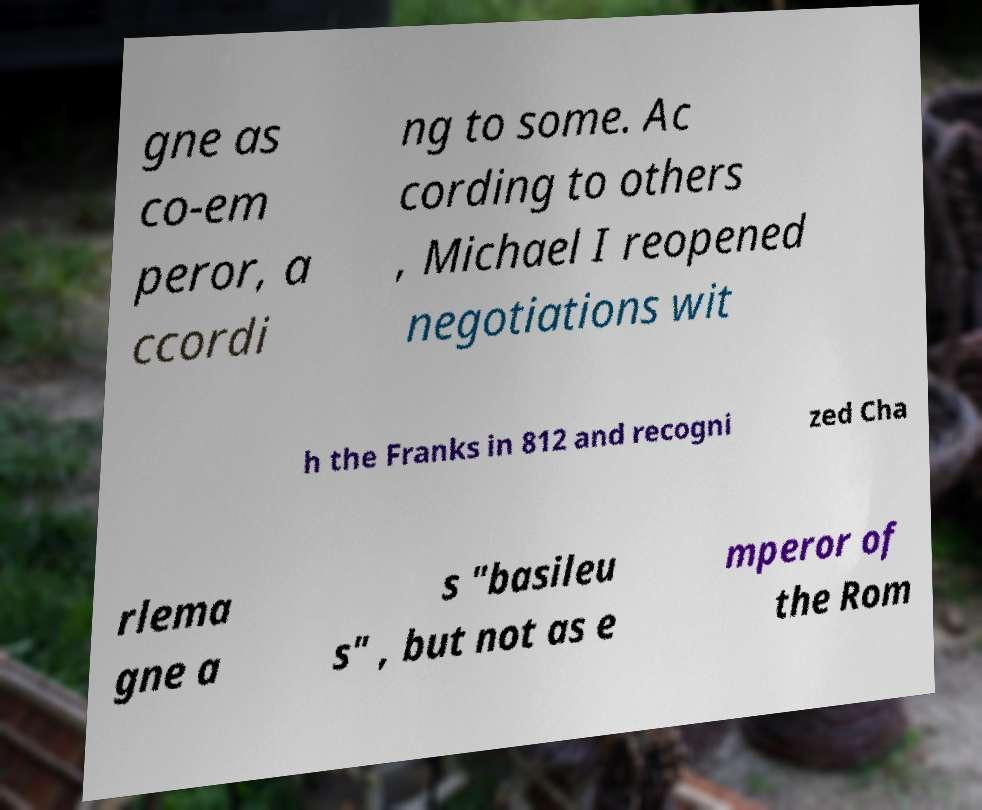For documentation purposes, I need the text within this image transcribed. Could you provide that? gne as co-em peror, a ccordi ng to some. Ac cording to others , Michael I reopened negotiations wit h the Franks in 812 and recogni zed Cha rlema gne a s "basileu s" , but not as e mperor of the Rom 